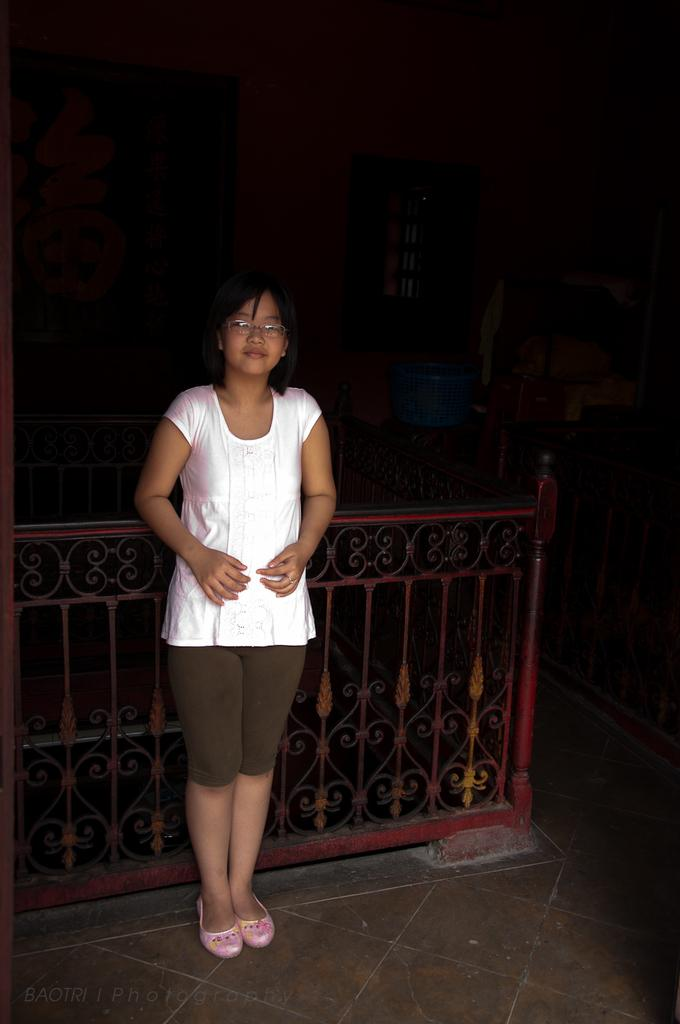What is the primary subject in the image? There is a person standing in the image. Where is the person standing? The person is standing on the floor. What can be seen in the cupboards in the image? Clothes are arranged in cupboards. What architectural features are present in the image? There are iron grills, a window, and a door in the image. What type of structure is visible in the image? Walls are present in the image. What type of doctor can be seen examining the person's tongue in the image? There is no doctor or tongue present in the image; it only features a person standing on the floor and various architectural features. 